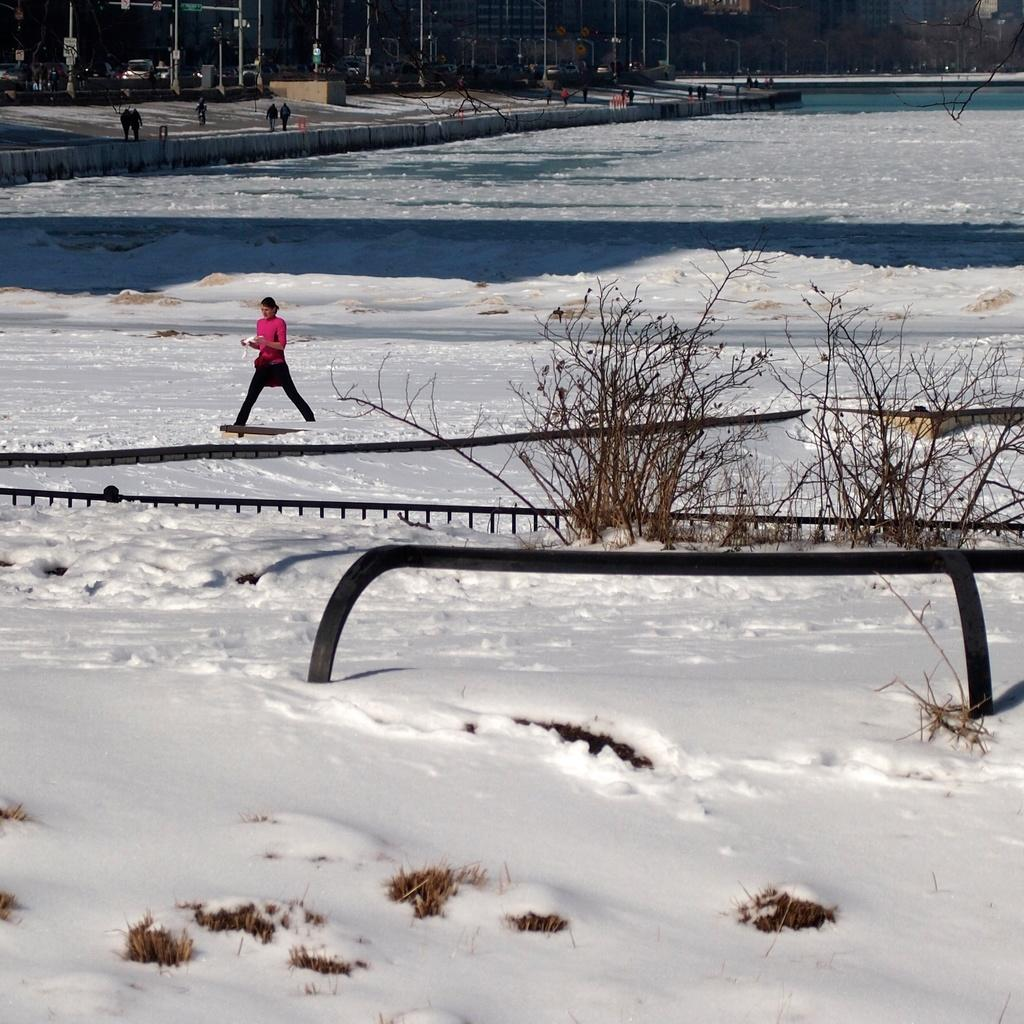What activity is the person in the image engaged in? The person in the image is skating on the snow. What can be seen in the background of the image? There are poles, people, and trees visible in the background of the image. What type of noise can be heard coming from the copper in the image? There is no copper present in the image, and therefore no noise can be heard from it. 